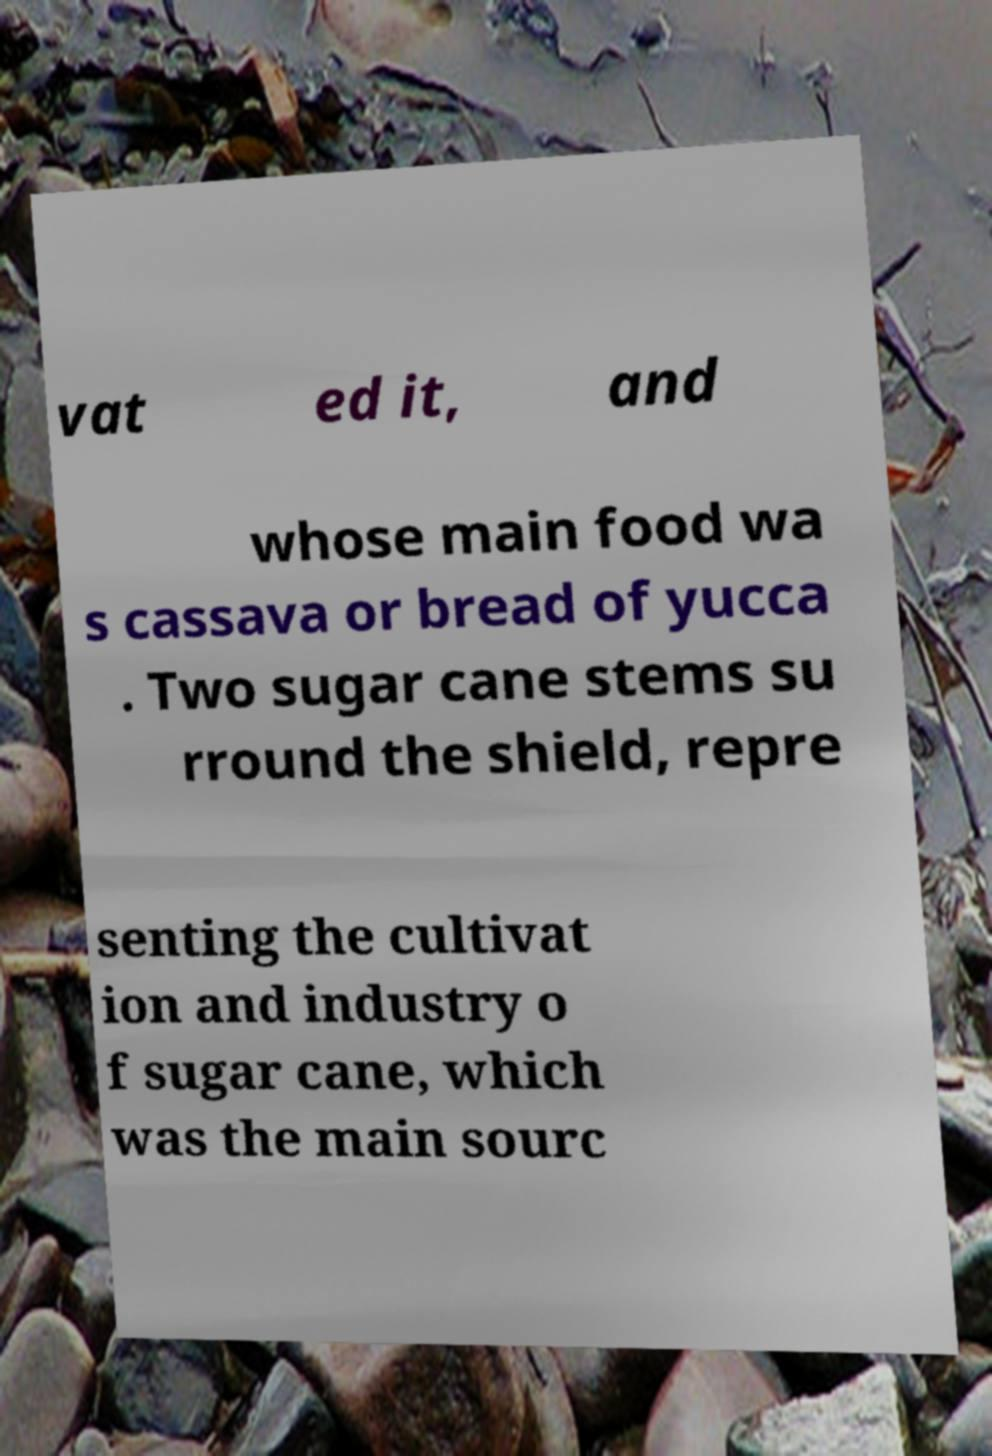Could you assist in decoding the text presented in this image and type it out clearly? vat ed it, and whose main food wa s cassava or bread of yucca . Two sugar cane stems su rround the shield, repre senting the cultivat ion and industry o f sugar cane, which was the main sourc 